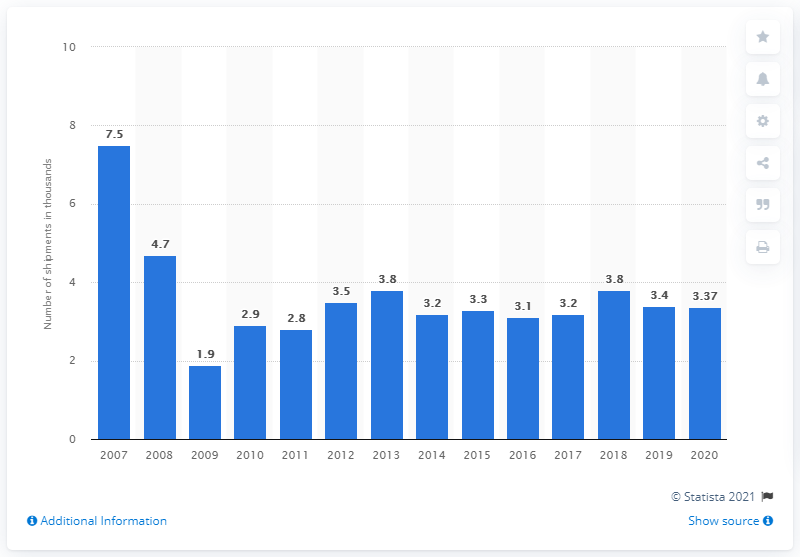Specify some key components in this picture. In 2020, a total of 3,370 truck campers were shipped from manufacturers to dealers in the United States. 